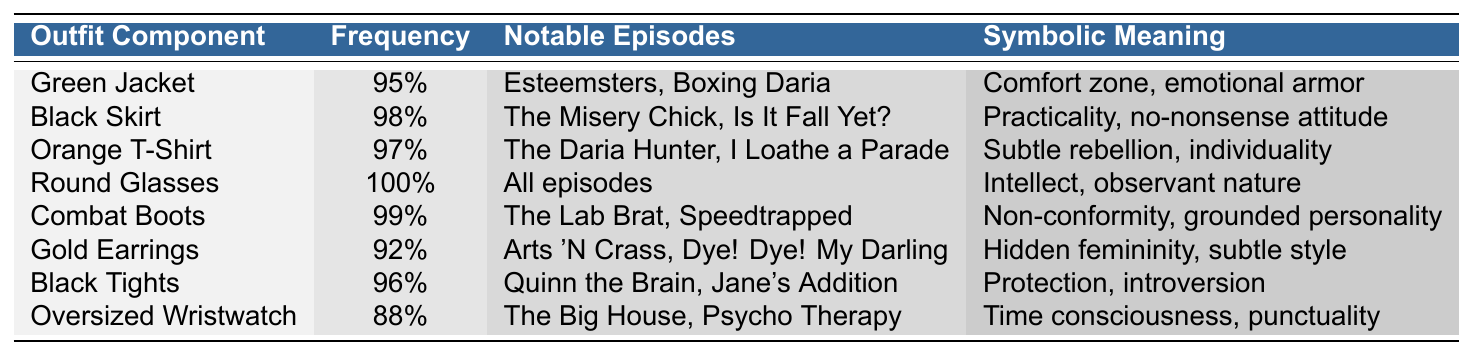What is the frequency of Daria's round glasses in her outfit choices? The table indicates that the frequency of round glasses is listed as 100%.
Answer: 100% Which outfit component appears most frequently in the series? The component with the highest frequency is the round glasses at 100%.
Answer: Round glasses How many outfit components have a frequency of 95% or higher? By examining the frequency column, we see that there are 7 outfit components with a frequency of 95% or higher (Green Jacket, Black Skirt, Orange T-Shirt, Round Glasses, Combat Boots, Black Tights, Gold Earrings).
Answer: 7 Are gold earrings worn in all episodes? No, according to the table, gold earrings appear in 92% of the episodes, while round glasses are the only component worn in all episodes.
Answer: No What outfit components symbolize Daria's non-conformity? Non-conformity is symbolized by the combat boots, which have a frequency of 99%.
Answer: Combat Boots What is the combined frequency of Daria's black skirt and orange t-shirt? The frequency of the black skirt is 98%, and the orange t-shirt is 97%. Adding these gives us 98 + 97 = 195.
Answer: 195 In how many notable episodes does Daria wear her combat boots? The table lists "The Lab Brat" and "Speedtrapped" as notable episodes for combat boots, indicating Daria wears them in 2 episodes.
Answer: 2 Does Daria's black tights represent a no-nonsense attitude? No, the black tights are associated with protection and introversion, while the black skirt reflects a no-nonsense attitude.
Answer: No Which outfit component has the lowest frequency? The oversized wristwatch has the lowest frequency at 88%.
Answer: Oversized Wristwatch Is there a clear pattern of Daria's outfit choices representing her personality? Yes, the table illustrates a consistent theme where components reflect her intellect, individuality, and non-conformity.
Answer: Yes 